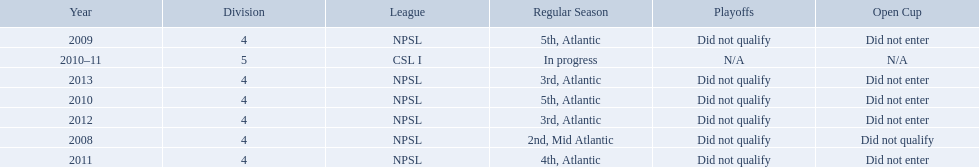What are the leagues? NPSL, NPSL, NPSL, CSL I, NPSL, NPSL, NPSL. Of these, what league is not npsl? CSL I. 